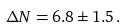<formula> <loc_0><loc_0><loc_500><loc_500>\Delta N = 6 . 8 \pm 1 . 5 \, .</formula> 